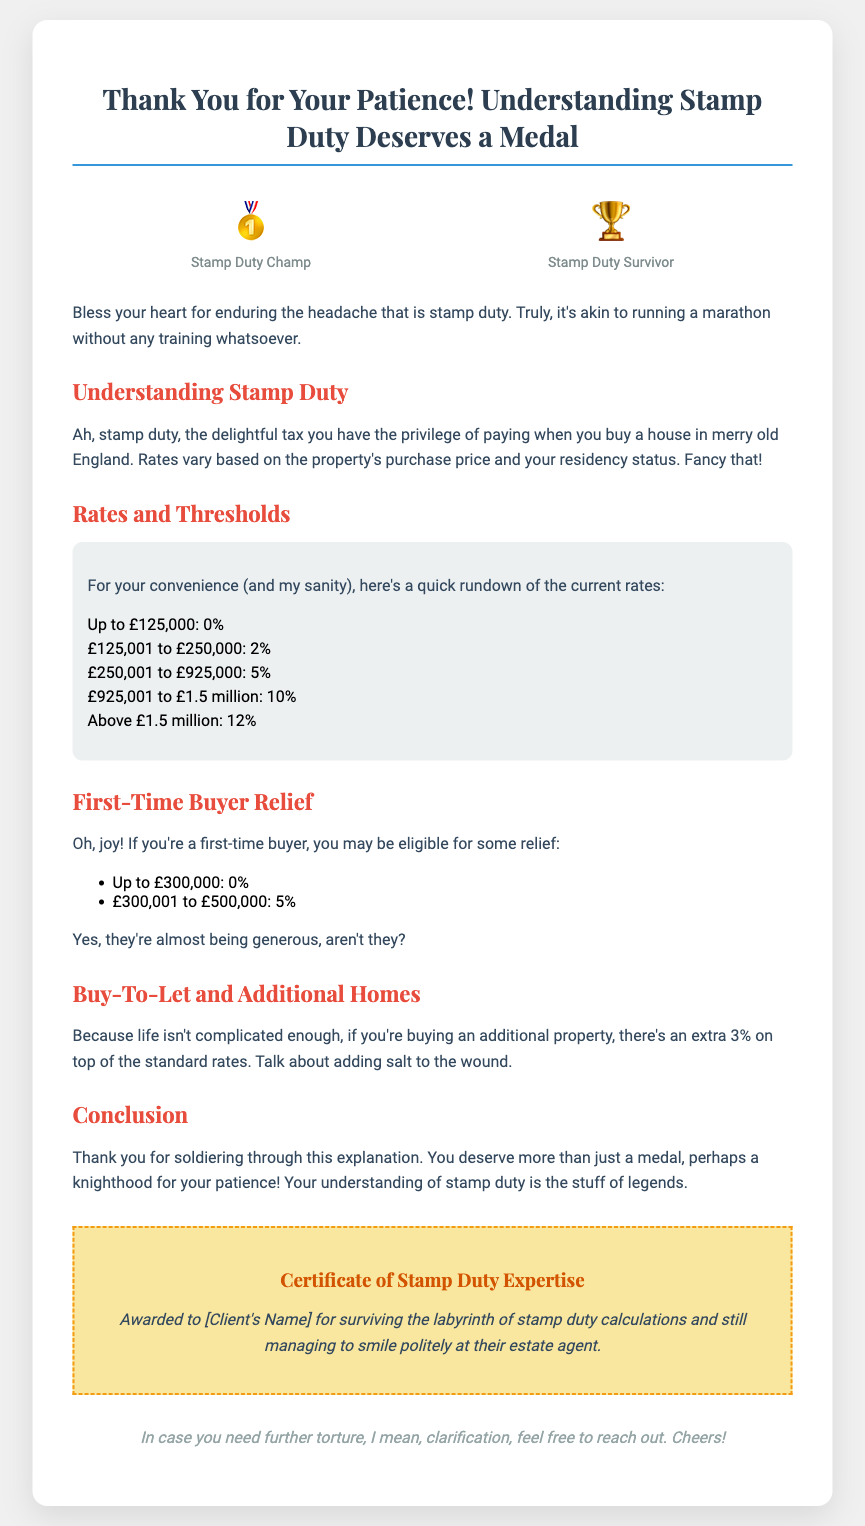What is the title of the card? The title of the card is central to its theme, highlighting the main focus of the document.
Answer: Thank You for Your Patience! Understanding Stamp Duty Deserves a Medal What is the first rate threshold for stamp duty? The first threshold mentioned in the rates section provides the starting point for stamp duty calculations.
Answer: Up to £125,000: 0% What extra percentage is charged for additional properties? The mention of an additional charge provides insight into the complexities of stamp duty for multiple purchases.
Answer: 3% What is awarded to clients for understanding stamp duty? The document contains a humorous certificate celebrating client endurance with a specific title.
Answer: Certificate of Stamp Duty Expertise How much is stamp duty for first-time buyers up to £300,000? This rate indicates a special consideration for first-time buyers and their financial relief.
Answer: 0% What type of medal is depicted for stamp duty survivors? The illustration adds a humorous touch, representing resilience in facing stamp duty.
Answer: 🏆 What color is the certificate border? The color detail of the certificate border highlights its playful and unique design meant for celebration.
Answer: Yellow What emotion does the card convey towards clients? The tone of the card adds a layer of understanding and appreciation for the client's experience with stamp duty.
Answer: Gratitude 